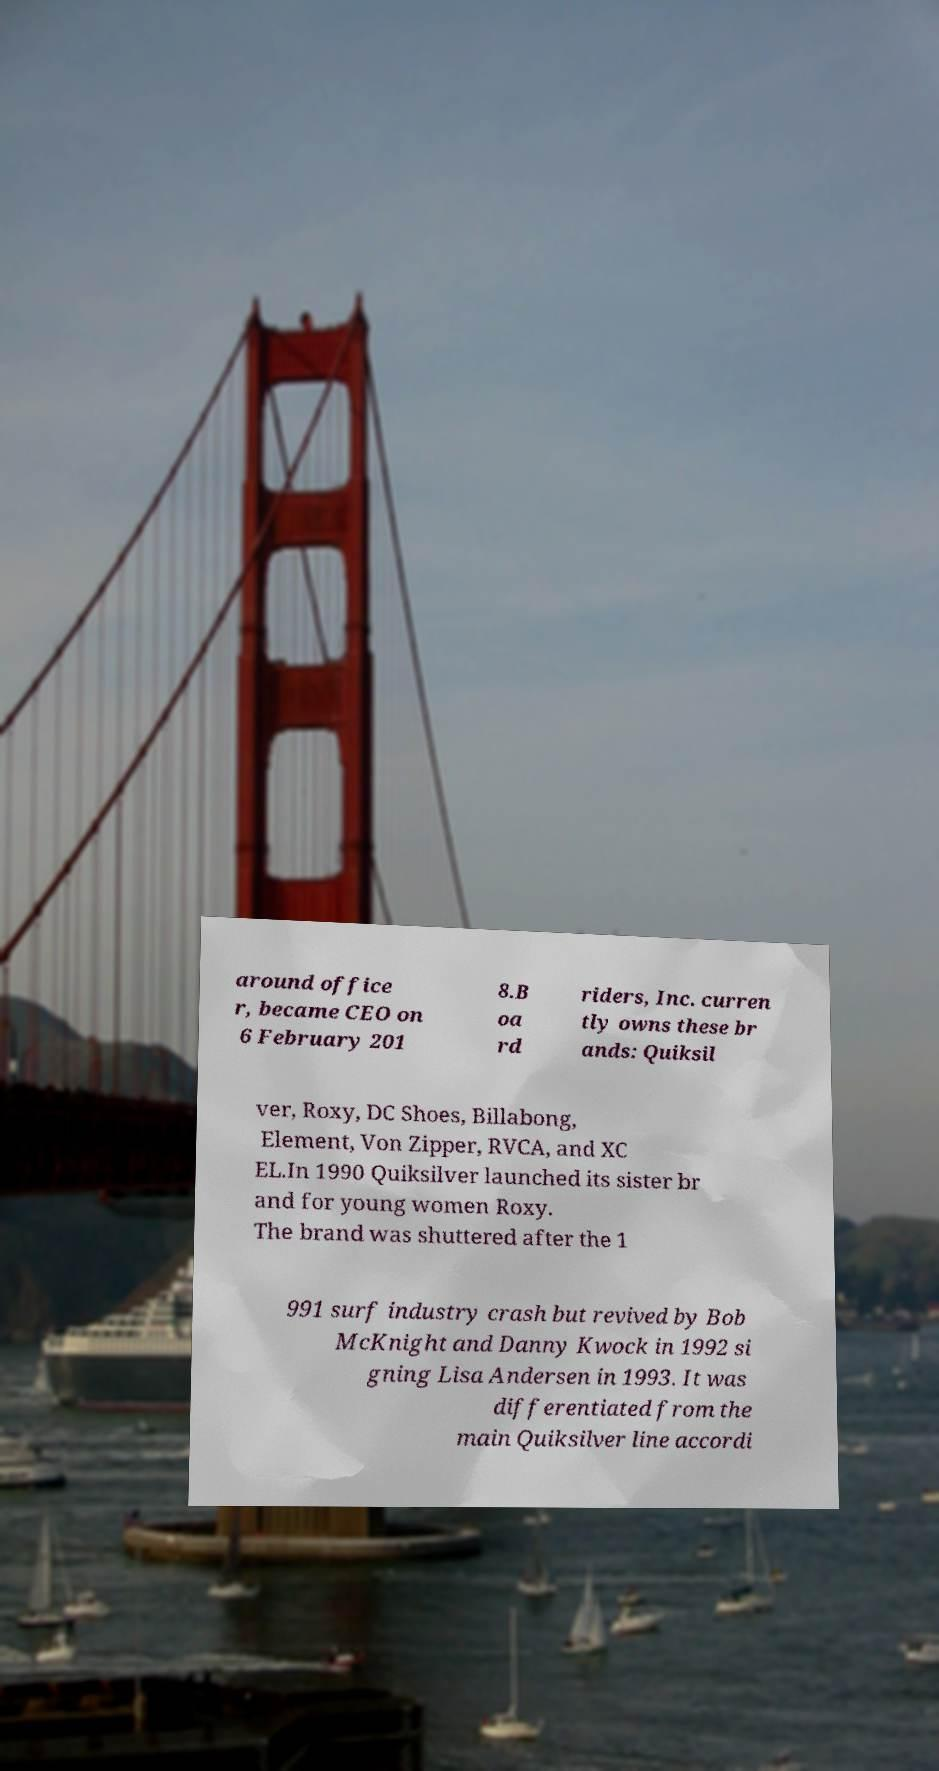Please identify and transcribe the text found in this image. around office r, became CEO on 6 February 201 8.B oa rd riders, Inc. curren tly owns these br ands: Quiksil ver, Roxy, DC Shoes, Billabong, Element, Von Zipper, RVCA, and XC EL.In 1990 Quiksilver launched its sister br and for young women Roxy. The brand was shuttered after the 1 991 surf industry crash but revived by Bob McKnight and Danny Kwock in 1992 si gning Lisa Andersen in 1993. It was differentiated from the main Quiksilver line accordi 